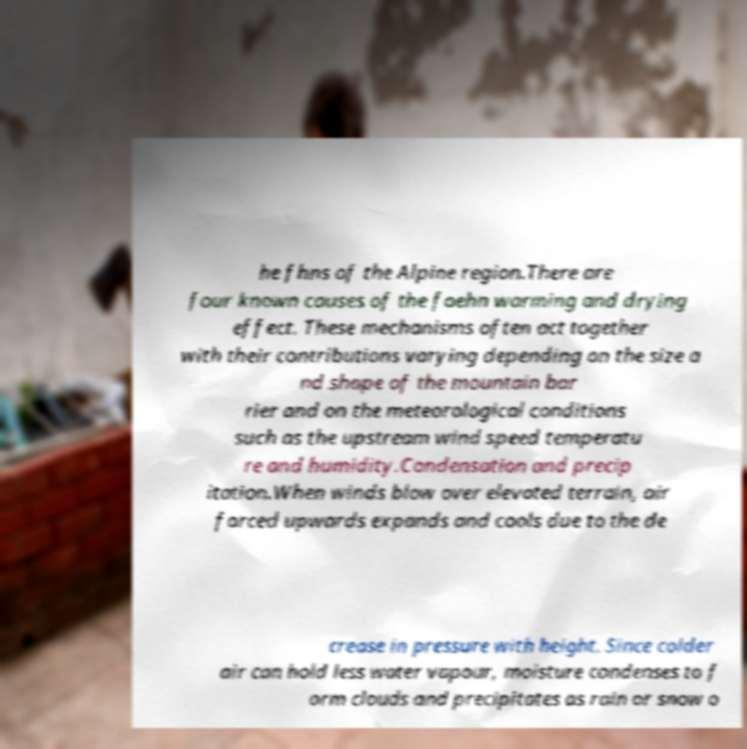Could you extract and type out the text from this image? he fhns of the Alpine region.There are four known causes of the foehn warming and drying effect. These mechanisms often act together with their contributions varying depending on the size a nd shape of the mountain bar rier and on the meteorological conditions such as the upstream wind speed temperatu re and humidity.Condensation and precip itation.When winds blow over elevated terrain, air forced upwards expands and cools due to the de crease in pressure with height. Since colder air can hold less water vapour, moisture condenses to f orm clouds and precipitates as rain or snow o 